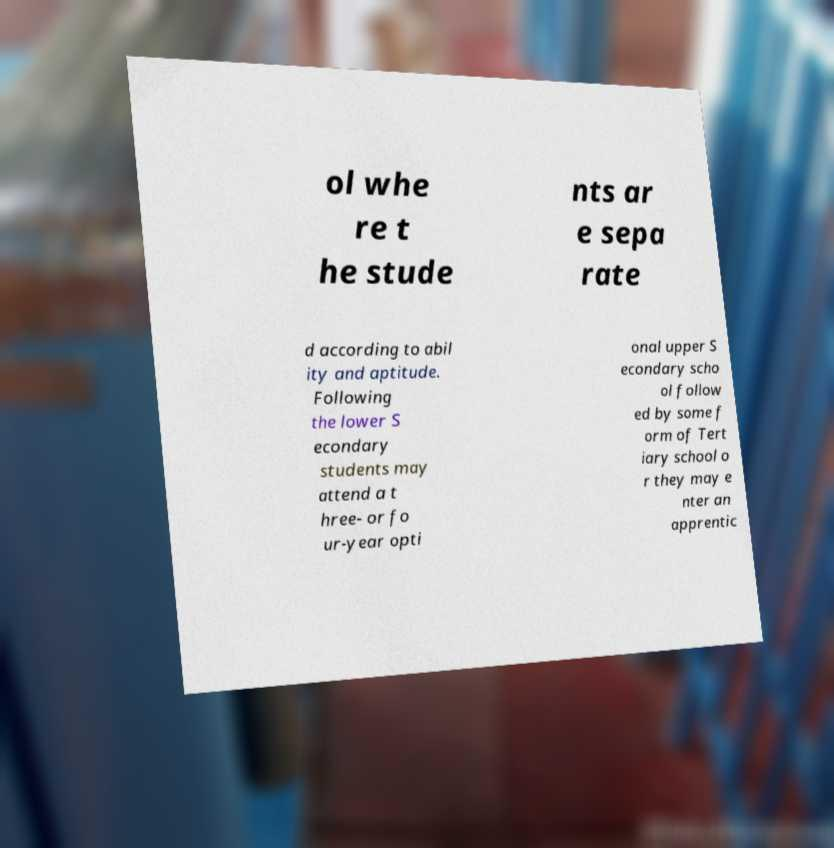I need the written content from this picture converted into text. Can you do that? ol whe re t he stude nts ar e sepa rate d according to abil ity and aptitude. Following the lower S econdary students may attend a t hree- or fo ur-year opti onal upper S econdary scho ol follow ed by some f orm of Tert iary school o r they may e nter an apprentic 